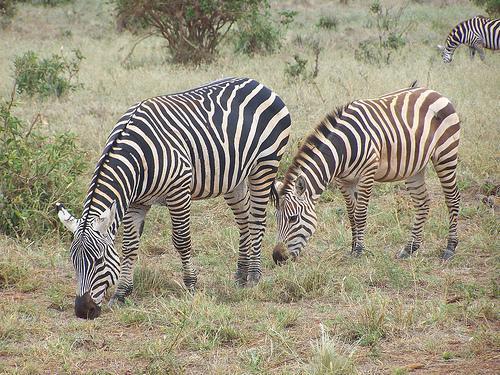How many zebras are shown?
Give a very brief answer. 3. 